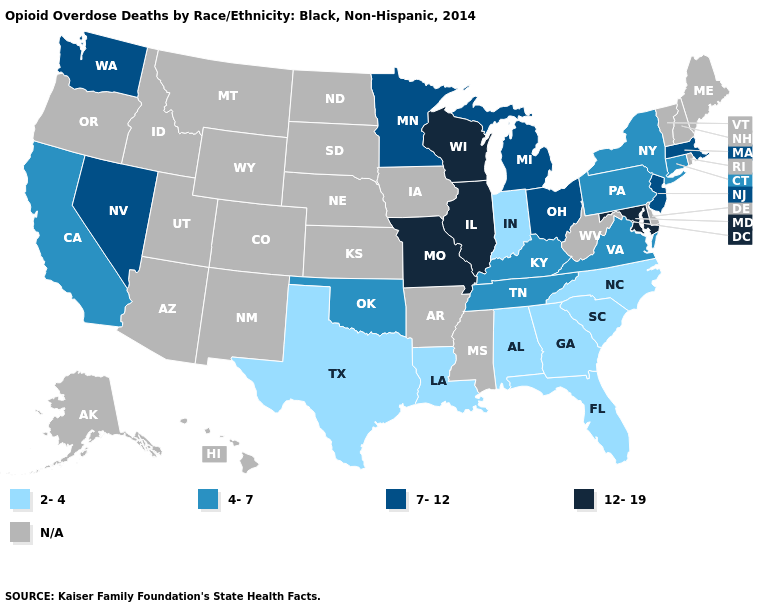What is the lowest value in the USA?
Concise answer only. 2-4. What is the value of Colorado?
Keep it brief. N/A. Does Washington have the lowest value in the West?
Be succinct. No. Among the states that border Michigan , does Indiana have the lowest value?
Short answer required. Yes. Among the states that border Ohio , which have the highest value?
Answer briefly. Michigan. What is the value of Kentucky?
Write a very short answer. 4-7. What is the highest value in the MidWest ?
Give a very brief answer. 12-19. Name the states that have a value in the range 4-7?
Quick response, please. California, Connecticut, Kentucky, New York, Oklahoma, Pennsylvania, Tennessee, Virginia. Which states have the highest value in the USA?
Give a very brief answer. Illinois, Maryland, Missouri, Wisconsin. Does Indiana have the lowest value in the USA?
Be succinct. Yes. Name the states that have a value in the range 4-7?
Give a very brief answer. California, Connecticut, Kentucky, New York, Oklahoma, Pennsylvania, Tennessee, Virginia. What is the value of Connecticut?
Write a very short answer. 4-7. What is the lowest value in the USA?
Be succinct. 2-4. 